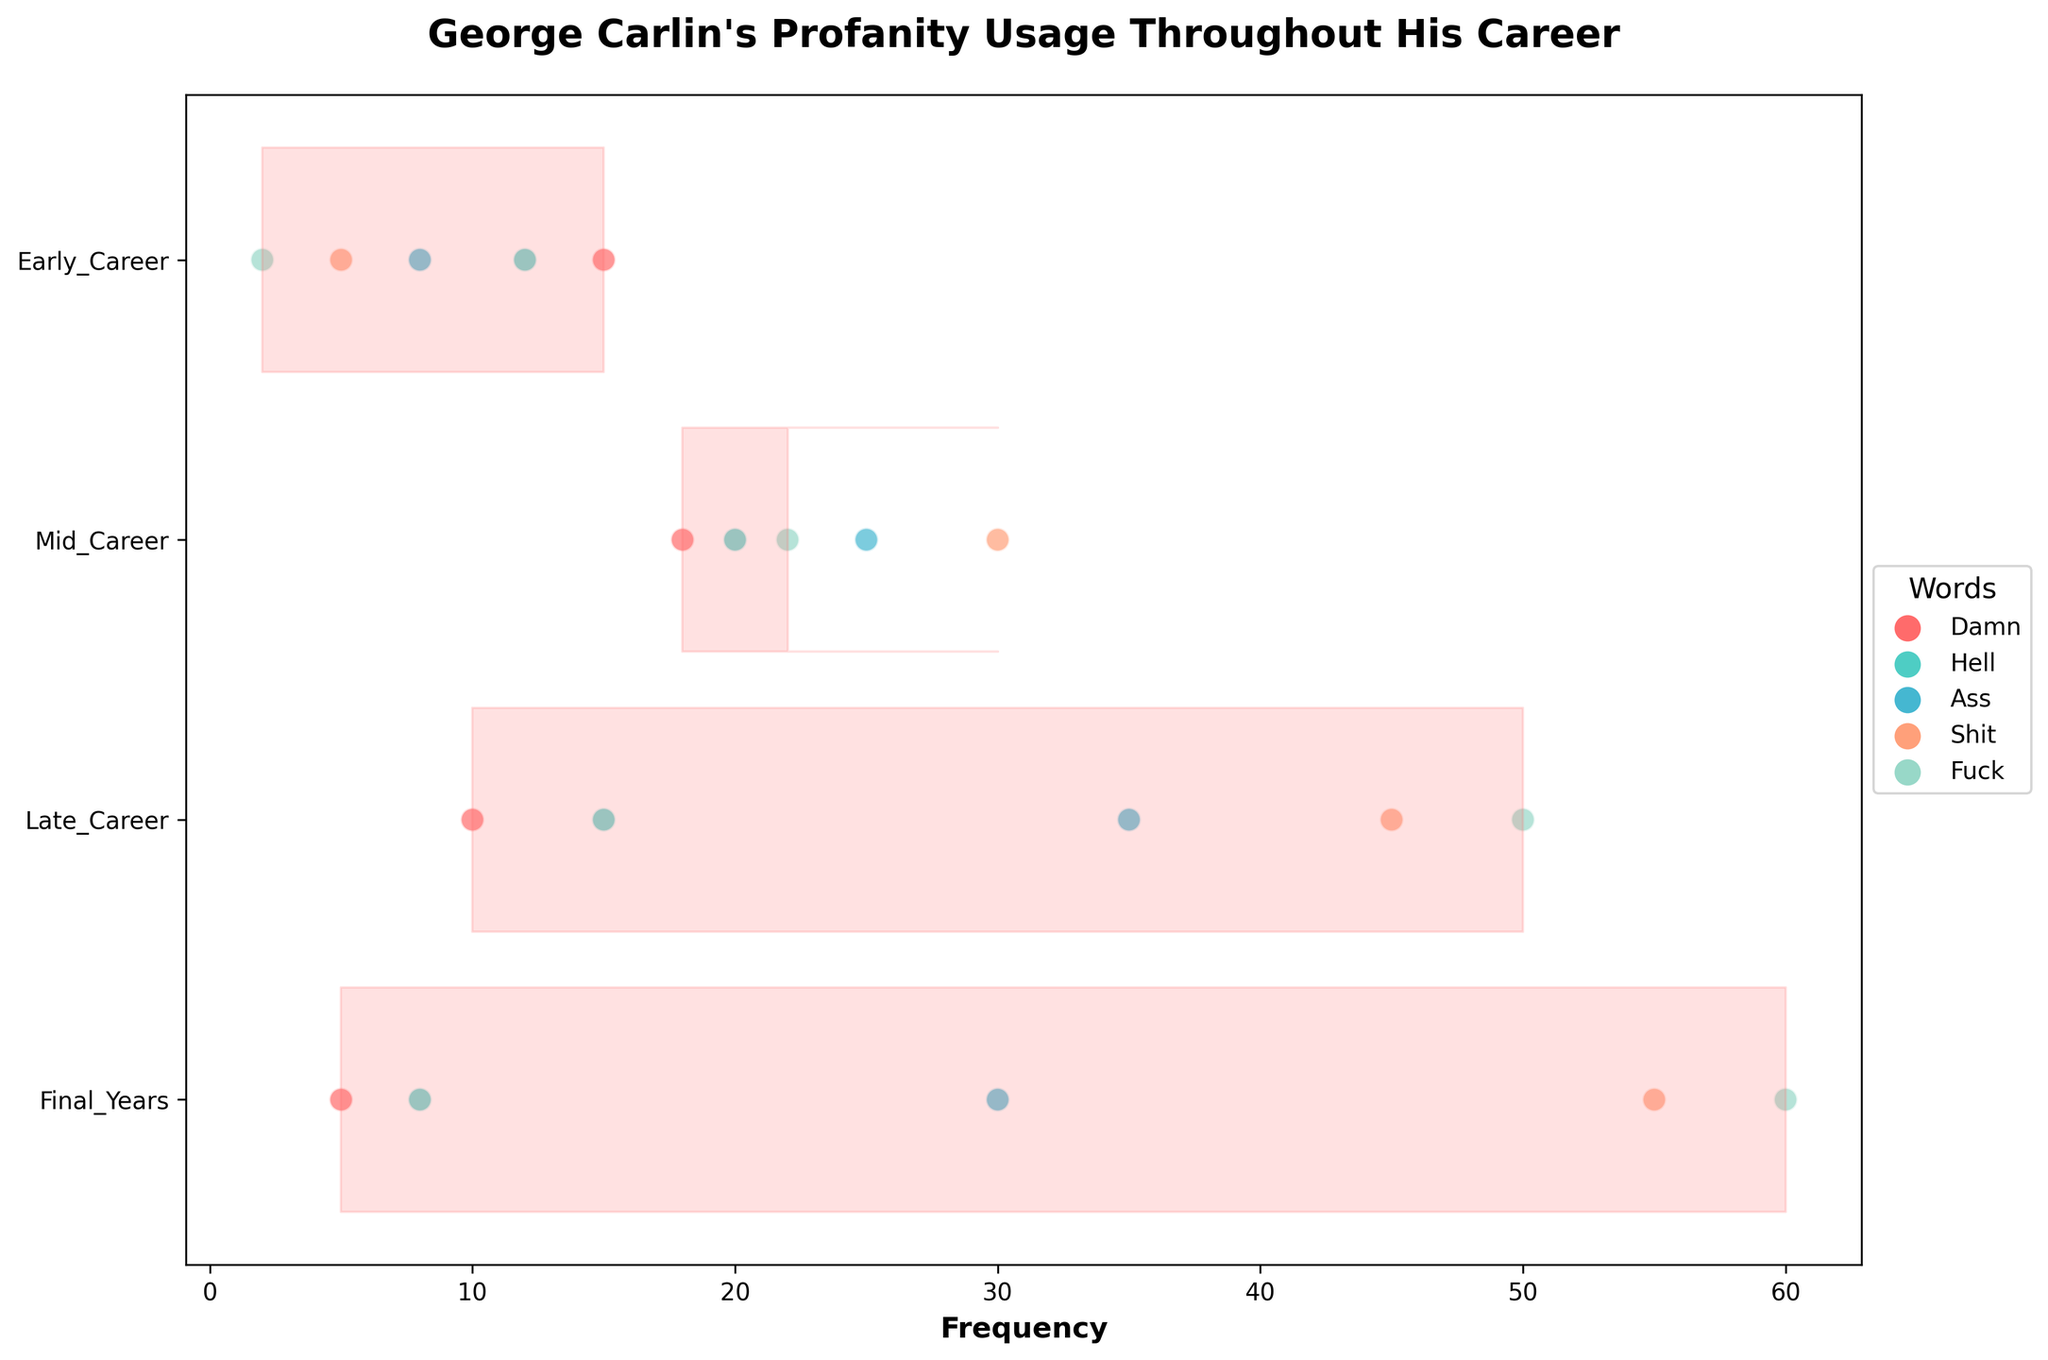What is the title of the plot? The title is displayed at the top of the figure and describes what the plot is about.
Answer: George Carlin's Profanity Usage Throughout His Career Which career stage shows the highest frequency of the word "Fuck"? Review the ridgeline plot and look at the heights of the scatter points specifically labeled with "Fuck" across the different career stages.
Answer: Final_Years How does the frequency of the word "Shit" change from Early_Career to Late_Career? Compare the heights of the scatter points labeled "Shit" between Early_Career and Late_Career observed on the plot.
Answer: It increases Which word had a sharp rise in usage during the Mid_Career stage? Observe the plot for a visible change or increase in the height of the scatter points for each word in the Mid_Career stage compared to the Early_Career stage.
Answer: Fuck What is the most frequently used word in the Late_Career stage? Look at the scatter points in the Late_Career stage and identify which word label has the highest point.
Answer: Fuck Is the frequency of profanity usage higher in the Final_Years compared to the Early_Career stage? Compare the scatter point heights across the Final_Years and Early_Career stages for all words listed on the plot.
Answer: Yes Compare the frequency of the words "Ass" and "Damn" in the Late_Career stage. Which one is higher? Look at the scatter points for both words in the Late_Career stage and compare their heights.
Answer: Ass Which stage of Carlin's career had the lowest usage of "Damn"? Identify the lowest scatter point labeled "Damn" across all career stages in the plot.
Answer: Final_Years What trend can you observe regarding the word "Shit" over Carlin's career? Examine the progression of the scatter points labeled "Shit" from Early_Career to Final_Years to identify any visible trend.
Answer: Increasing How did the usage of "Hell" change from Early_Career to Mid_Career? Observe the scatter points for the word "Hell" between Early_Career and Mid_Career stages and note the change in height.
Answer: It increased 